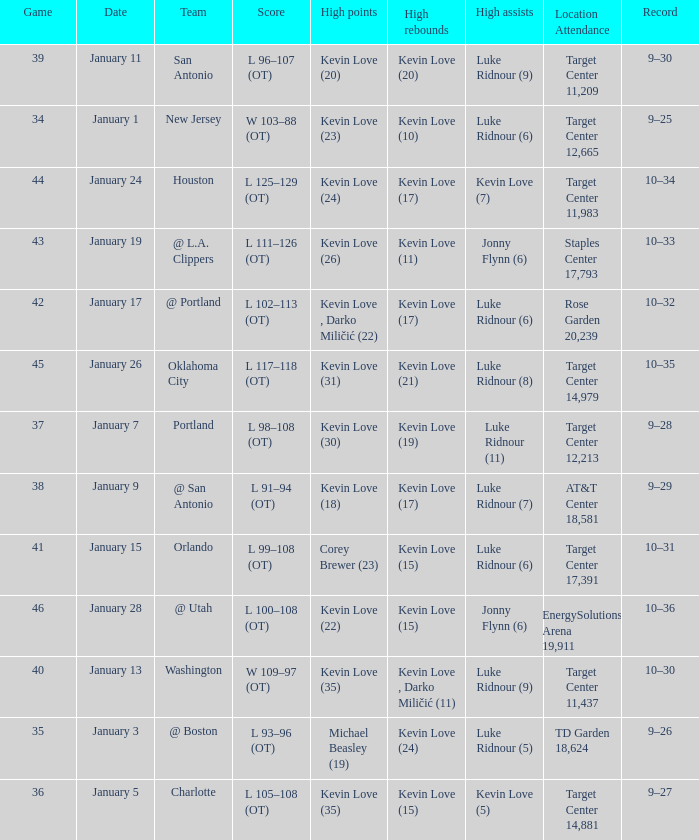How many times did kevin love (22) have the high points? 1.0. 